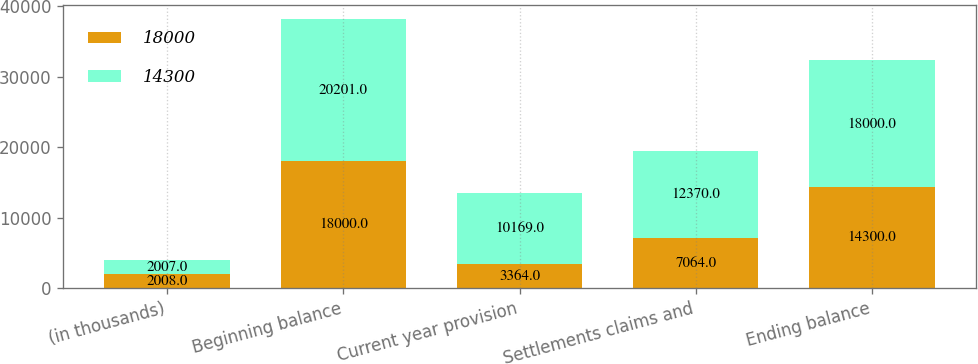Convert chart to OTSL. <chart><loc_0><loc_0><loc_500><loc_500><stacked_bar_chart><ecel><fcel>(in thousands)<fcel>Beginning balance<fcel>Current year provision<fcel>Settlements claims and<fcel>Ending balance<nl><fcel>18000<fcel>2008<fcel>18000<fcel>3364<fcel>7064<fcel>14300<nl><fcel>14300<fcel>2007<fcel>20201<fcel>10169<fcel>12370<fcel>18000<nl></chart> 